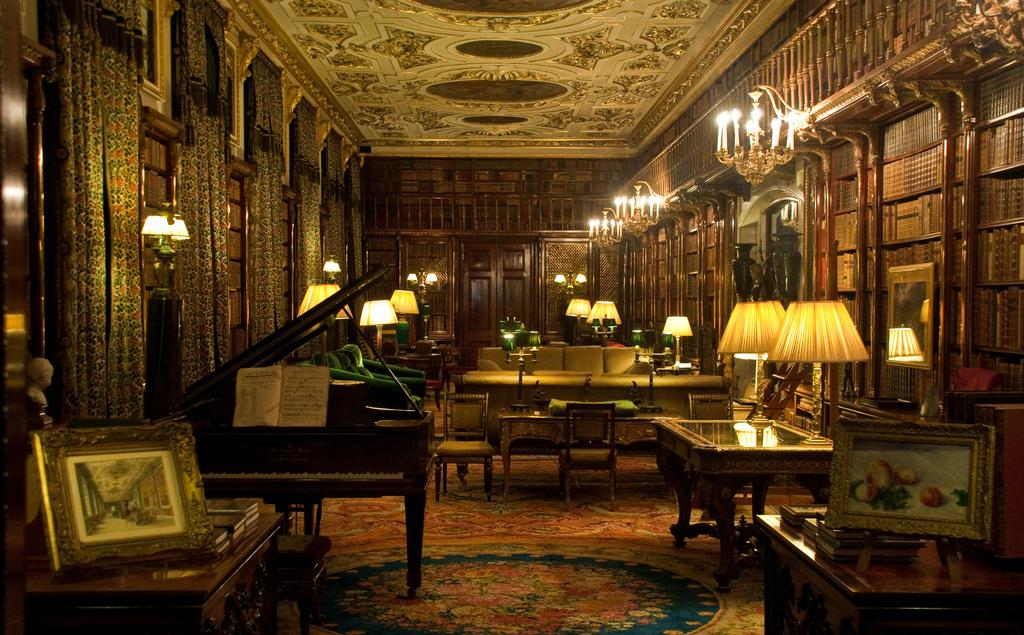What type of objects can be seen in the image that provide light? There are lamps and candles in the image that provide light. What type of objects can be seen in the image that hold pictures or artwork? There are frames in the image that hold pictures or artwork. What type of object can be seen in the image that is used for reading or learning? There is a book in the image that is used for reading or learning. What type of musical instrument can be seen in the image? There is a piano in the image. What type of window treatment can be seen in the image? There are curtains in the image. What type of furniture can be seen in the image that is used for seating? There are sofas in the image. How many books can be seen in the image? There are multiple books in the image. Where are the rabbits playing in the image? There are no rabbits present in the image. What type of road can be seen in the image? There is no road present in the image. What type of chalk can be seen in the image? There is no chalk present in the image. 